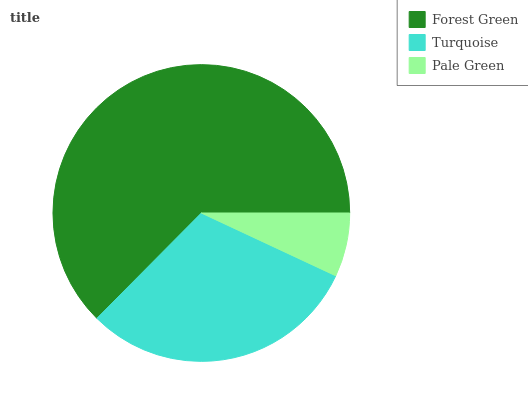Is Pale Green the minimum?
Answer yes or no. Yes. Is Forest Green the maximum?
Answer yes or no. Yes. Is Turquoise the minimum?
Answer yes or no. No. Is Turquoise the maximum?
Answer yes or no. No. Is Forest Green greater than Turquoise?
Answer yes or no. Yes. Is Turquoise less than Forest Green?
Answer yes or no. Yes. Is Turquoise greater than Forest Green?
Answer yes or no. No. Is Forest Green less than Turquoise?
Answer yes or no. No. Is Turquoise the high median?
Answer yes or no. Yes. Is Turquoise the low median?
Answer yes or no. Yes. Is Forest Green the high median?
Answer yes or no. No. Is Forest Green the low median?
Answer yes or no. No. 